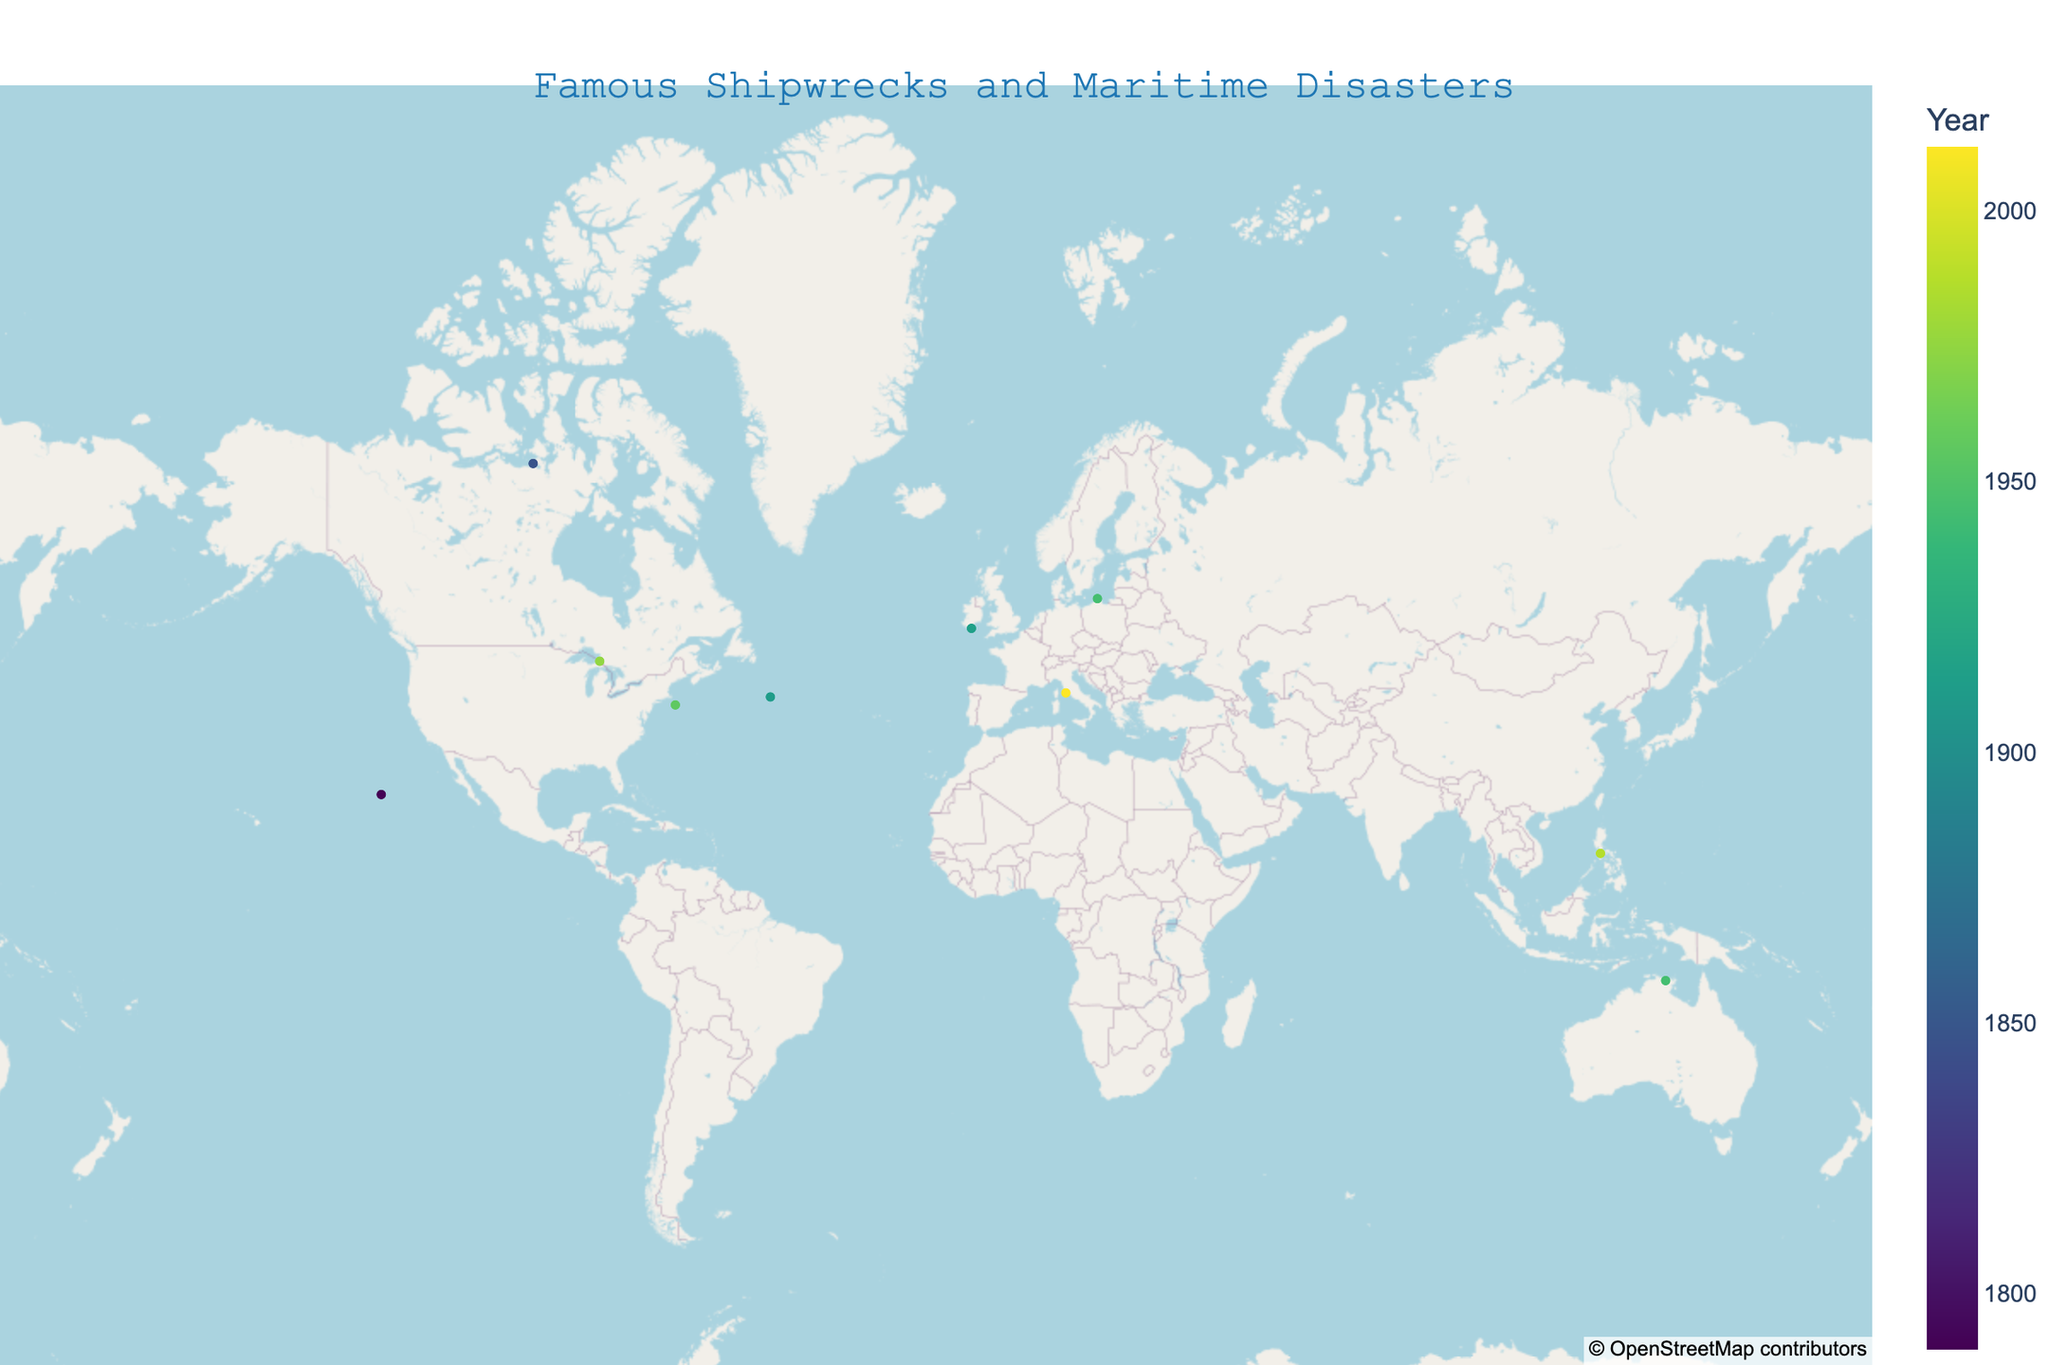What's the title of the figure? The title is prominently displayed at the top center of the figure in a larger font. The title reads "Famous Shipwrecks and Maritime Disasters".
Answer: Famous Shipwrecks and Maritime Disasters Which shipwreck occurred furthest north? By looking at the latitude values, the shipwreck with the highest latitude is the one furthest north. The HMS Terror, at a latitude of 68.0978, occurs furthest north.
Answer: HMS Terror How many shipwrecks occurred in the 20th century? We need to count the number of shipwrecks with years between 1901 and 2000. These are the RMS Titanic (1912), RMS Lusitania (1915), SS Andrea Doria (1956), USS Indianapolis (1945), SS Edmund Fitzgerald (1975), and MV Wilhelm Gustloff (1945). There are 6 shipwrecks in total.
Answer: 6 Which shipwreck is closest to the equator? The equator is at latitude 0. The shipwreck with the latitude closest to 0 is the USS Indianapolis at latitude -12.3479.
Answer: USS Indianapolis What is the distribution of shipwrecks over the centuries? By analyzing the years of the shipwrecks, we group them by century. The HMS Bounty (1790) belongs to the 18th century. The HMS Terror (1848) belongs to the 19th century. The others belong to the 20th and 21st centuries. So, 1 in the 18th, 1 in the 19th, 7 in the 20th, and 1 in the 21st.
Answer: 18th: 1, 19th: 1, 20th: 7, 21st: 1 Which shipwreck happened most recently? By observing the years, the most recent shipwreck is the Costa Concordia, which occurred in 2012.
Answer: Costa Concordia Compare the number of Atlantic Ocean and Pacific Ocean shipwrecks. The Atlantic Ocean shipwrecks include RMS Titanic, RMS Lusitania, SS Andrea Doria, and Costa Concordia. The Pacific Ocean shipwrecks include USS Indianapolis, HMS Bounty, and MV Doña Paz. There are 4 Atlantic shipwrecks and 3 Pacific shipwrecks.
Answer: Atlantic: 4, Pacific: 3 Which shipwreck is closest to Europe? The shipwreck with the closest longitude to Europe's typical boundaries (~-10 to 30) is RMS Lusitania, at longitude -8.5331.
Answer: RMS Lusitania What is the general trend of the years of shipwrecks on the plot? Observing the color gradient, which represents the years, we notice that the majority of shipwrecks, marked by deeper colors, occurred during the 20th century with a few exceptional cases before and after.
Answer: Concentration in the 20th century 